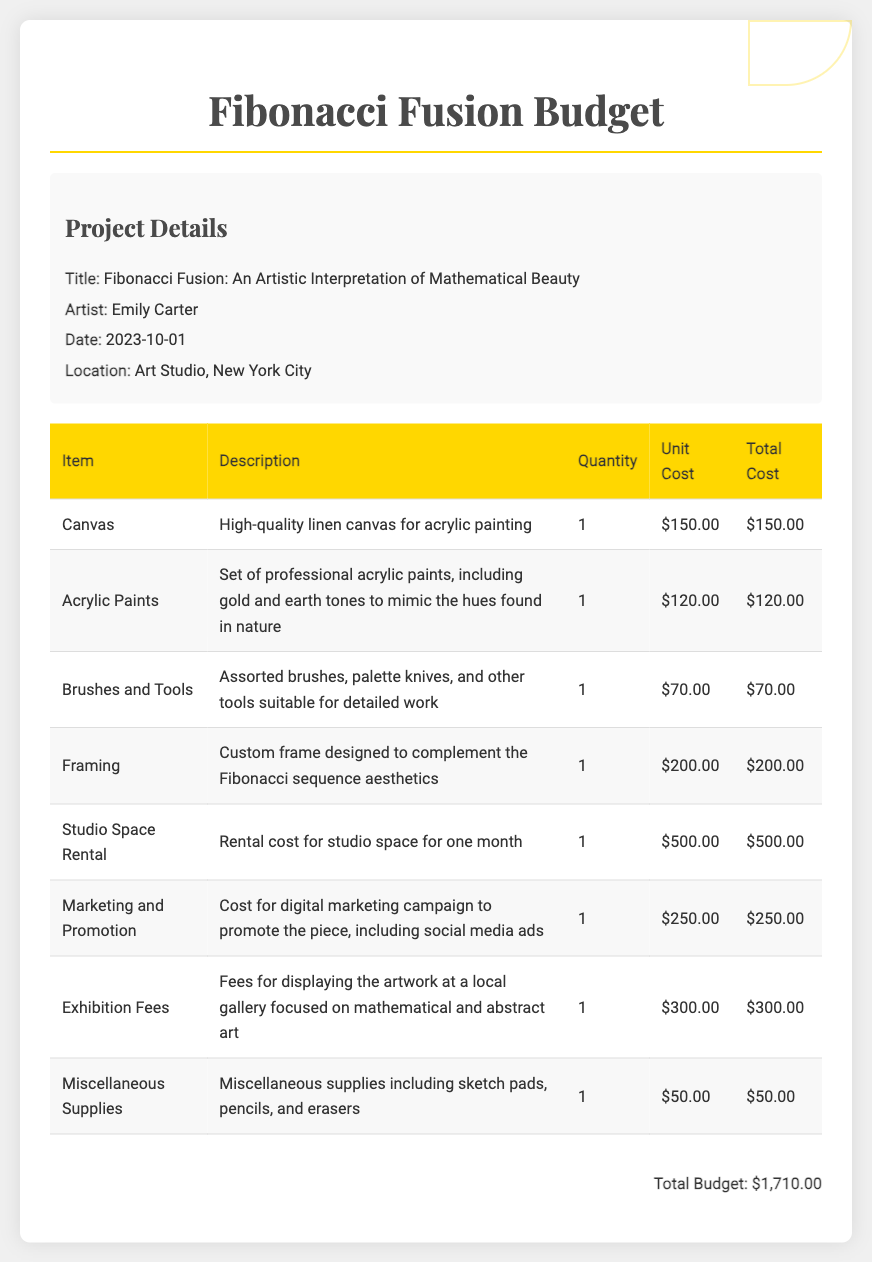What is the title of the project? The title of the project is explicitly mentioned in the document under project details.
Answer: Fibonacci Fusion: An Artistic Interpretation of Mathematical Beauty Who is the artist? The artist's name is provided in the project details section of the document.
Answer: Emily Carter What is the total budget? The total budget is summarized at the end of the document, showing the total costs of all items listed.
Answer: $1,710.00 How many items are listed in the budget? The number of items is counted from the table rows in the budget section.
Answer: 8 What is the cost of studio space rental? The cost for studio space rental is specified in the table with its corresponding item.
Answer: $500.00 What is the purpose of the marketing and promotion expense? The purpose of marketing and promotion is described in the document under the item description.
Answer: To promote the piece What type of canvas is used? The type of canvas is detailed in the item description for the canvas entry in the budget table.
Answer: High-quality linen canvas What is the description of acrylic paints? The description provides details on the type of paints being bought for the project.
Answer: Set of professional acrylic paints, including gold and earth tones to mimic the hues found in nature 